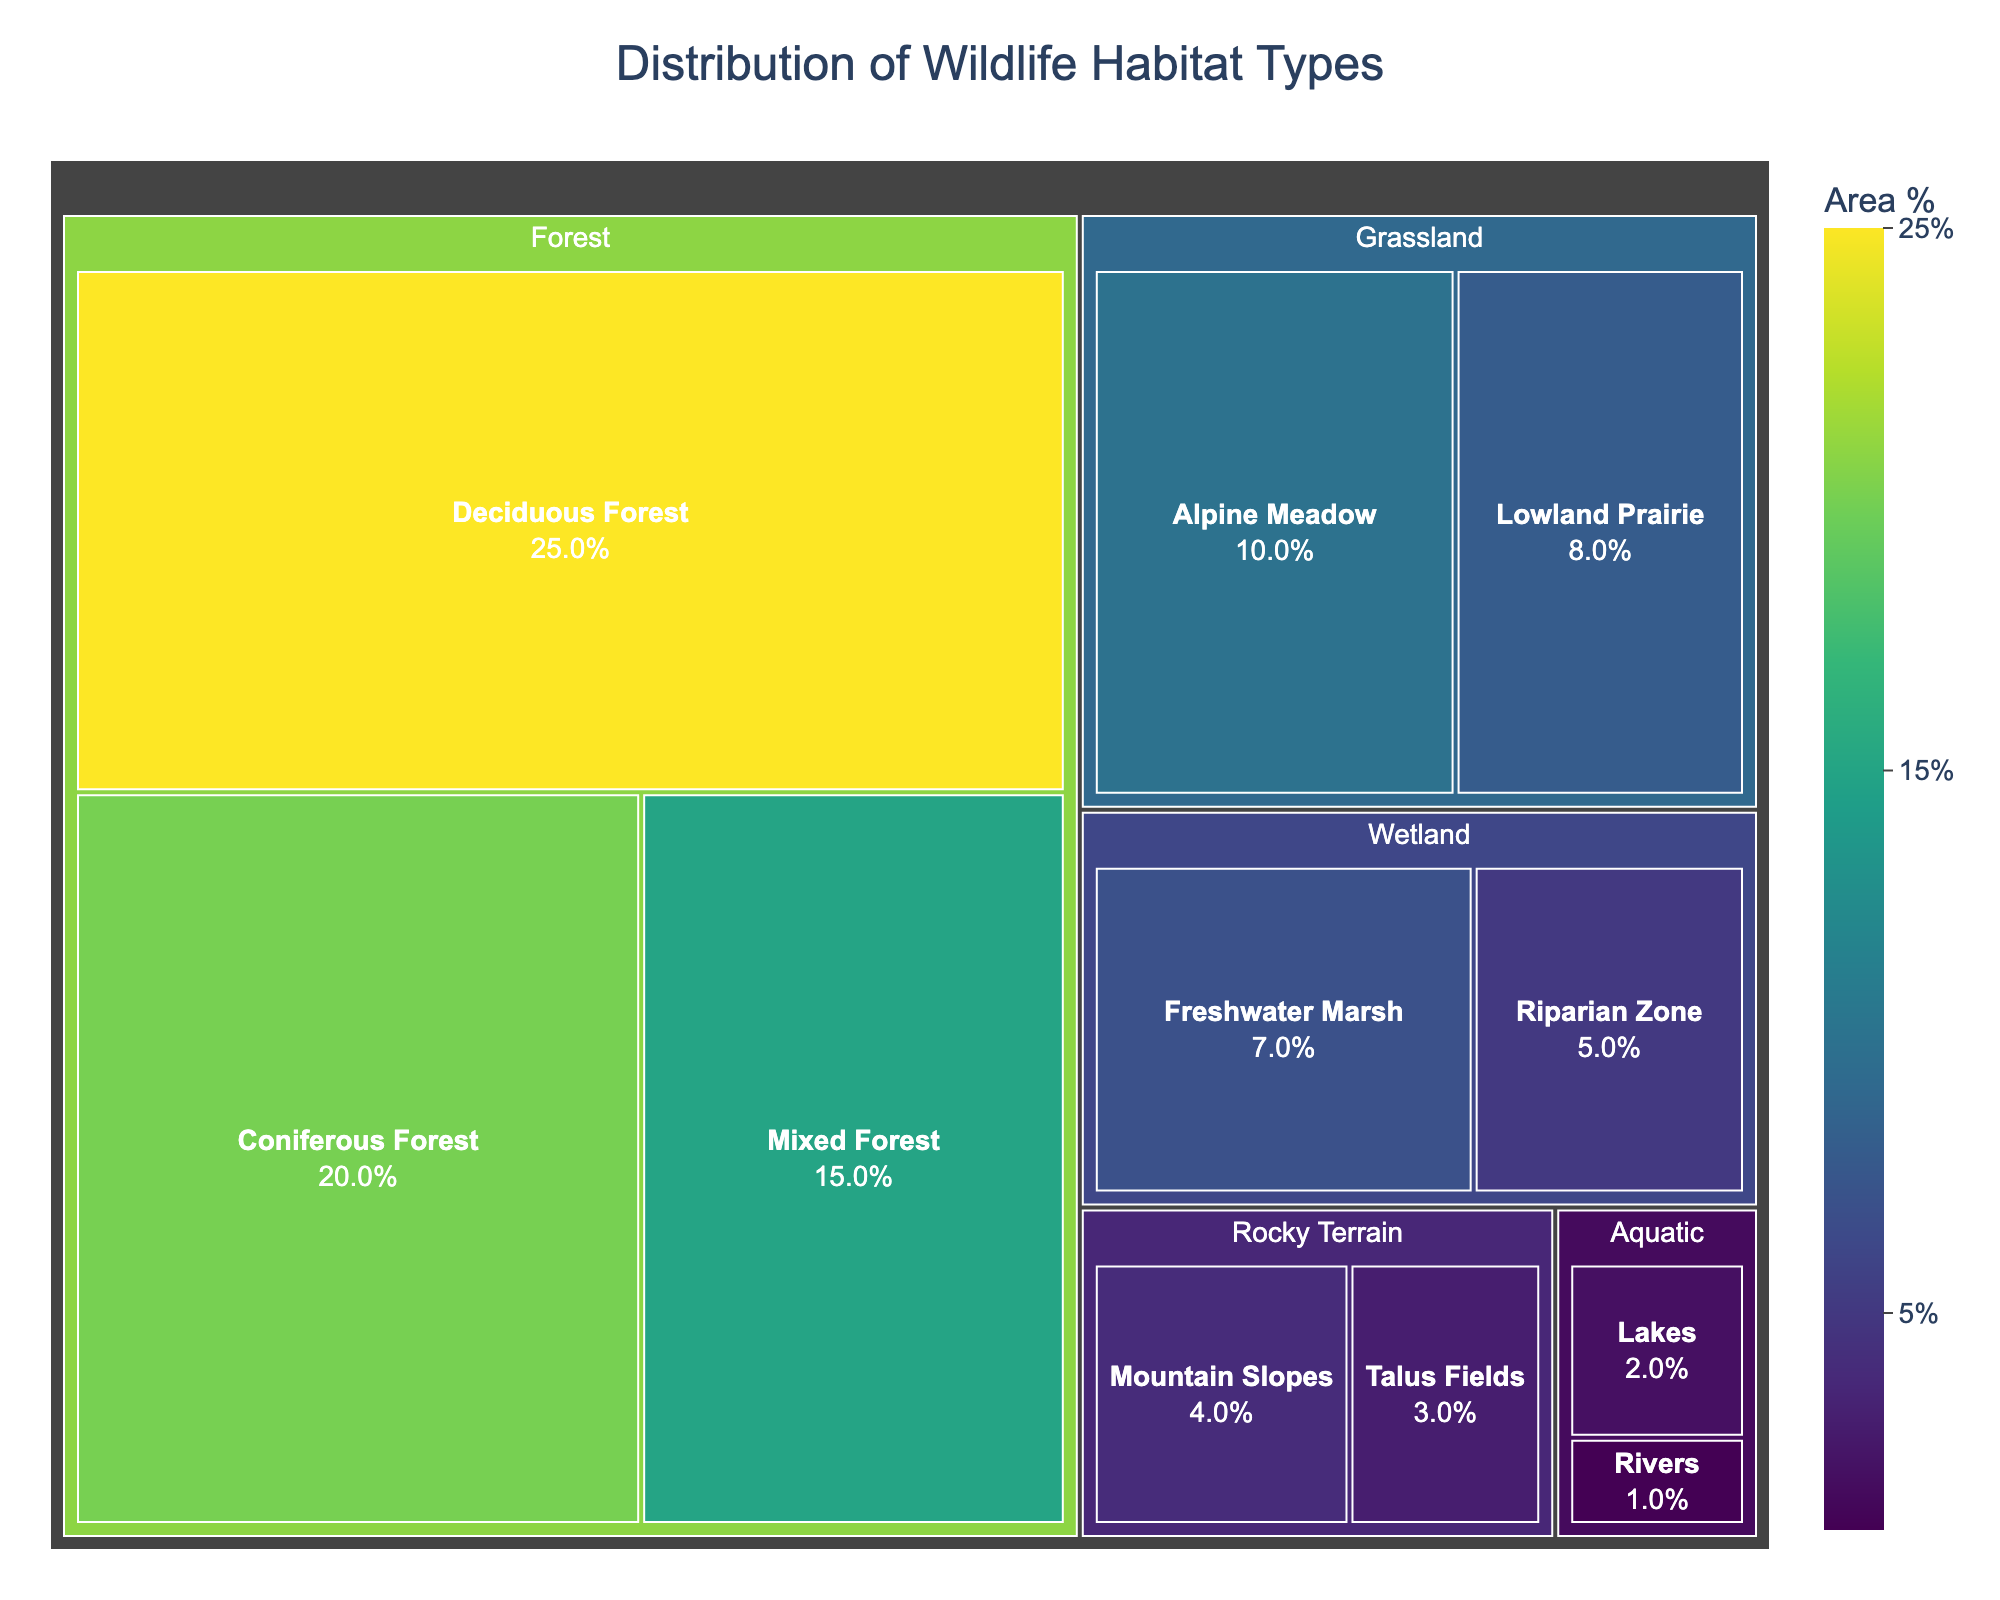what is the title of the figure? The title is usually placed prominently on top of the figure and provides a summary of what the figure represents.
Answer: Distribution of Wildlife Habitat Types How many habitat types are represented in the figure? The figure categorizes areas into different habitat types. Look for distinct top-level categories in the treemap. There are five visible top-level categories, each representing a habitat type.
Answer: 5 Which habitat type has the largest area percentage? In a treemap, the largest area is typically represented by the largest tile. In this figure, look for the largest tile size.
Answer: Deciduous Forest What is the combined area percentage of 'Alpine Meadow' and 'Lowland Prairie'? Identify the area percentages for 'Alpine Meadow' and 'Lowland Prairie'. Add these percentages together to get the combined value. Alpine Meadow is 10%, and Lowland Prairie is 8%. So, 10% + 8% = 18%.
Answer: 18% What's the difference in area percentage between the 'Mixed Forest' and 'Riparian Zone'? Identify the area percentages for 'Mixed Forest' and 'Riparian Zone'. Subtract the smaller percentage from the larger one. Mixed Forest is 15%, and Riparian Zone is 5%. So, 15% - 5% = 10%.
Answer: 10% Which has a larger area, 'Freshwater Marsh' or 'Mountain Slopes'? Compare the area percentages directly from the figure. Freshwater Marsh is 7%, and Mountain Slopes is 4%. Therefore, Freshwater Marsh has a larger area.
Answer: Freshwater Marsh How many percentage points less is 'Rivers' compared to 'Lakes'? Identify the area percentages for 'Rivers' and 'Lakes'. Subtract the area percentage of 'Rivers' from that of 'Lakes'. Lakes is 2%, and Rivers is 1%. So, 2% - 1% = 1%.
Answer: 1% Which vegetation type has the highest area percentage within the 'Forest' habitat type? Look within the 'Forest' habitat type to compare area percentages. Deciduous Forest has the highest percentage at 25%.
Answer: Deciduous Forest What's the total area percentage for 'Wetland' habitat type? Sum the area percentages of 'Freshwater Marsh' and 'Riparian Zone' under Wetland. Freshwater Marsh is 7%, and Riparian Zone is 5%. So, 7% + 5% = 12%.
Answer: 12% What is the smallest individual area percentage depicted in the treemap? Look for the smallest tile in the treemap to identify its label and area percentage. The smallest area percentage is 1%, which is for 'Rivers'.
Answer: 1% 